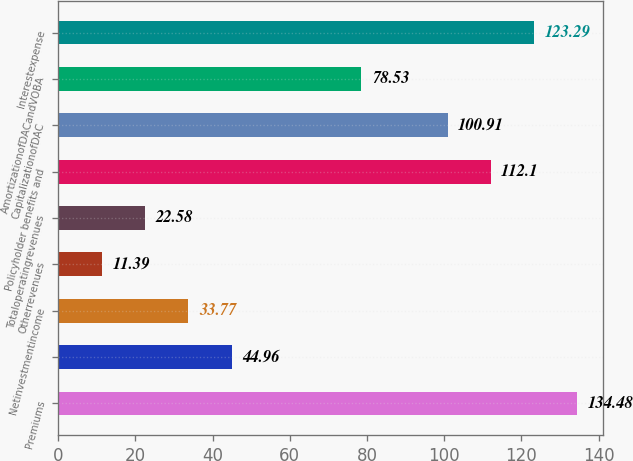Convert chart to OTSL. <chart><loc_0><loc_0><loc_500><loc_500><bar_chart><fcel>Premiums<fcel>Unnamed: 1<fcel>Netinvestmentincome<fcel>Otherrevenues<fcel>Totaloperatingrevenues<fcel>Policyholder benefits and<fcel>CapitalizationofDAC<fcel>AmortizationofDACandVOBA<fcel>Interestexpense<nl><fcel>134.48<fcel>44.96<fcel>33.77<fcel>11.39<fcel>22.58<fcel>112.1<fcel>100.91<fcel>78.53<fcel>123.29<nl></chart> 